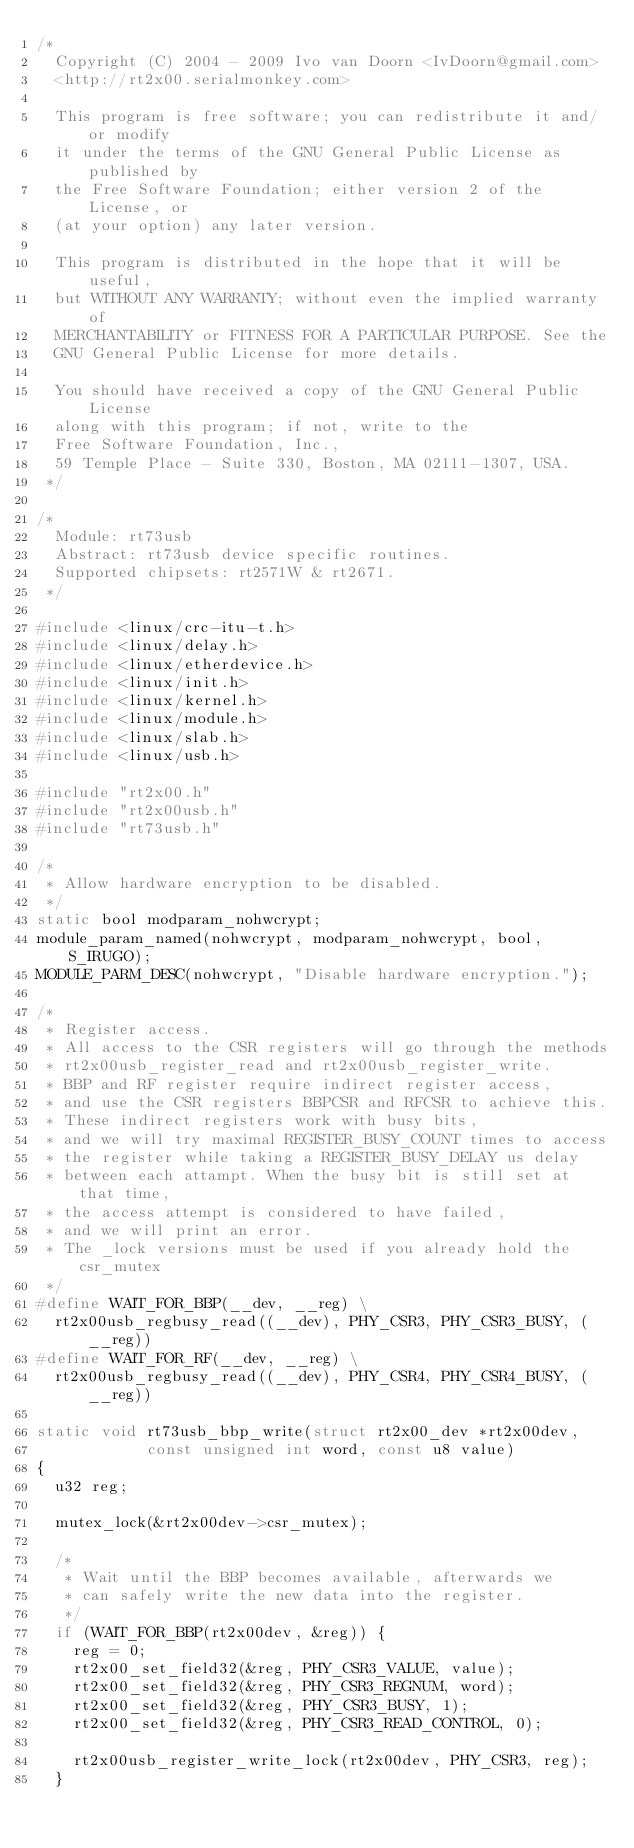<code> <loc_0><loc_0><loc_500><loc_500><_C_>/*
	Copyright (C) 2004 - 2009 Ivo van Doorn <IvDoorn@gmail.com>
	<http://rt2x00.serialmonkey.com>

	This program is free software; you can redistribute it and/or modify
	it under the terms of the GNU General Public License as published by
	the Free Software Foundation; either version 2 of the License, or
	(at your option) any later version.

	This program is distributed in the hope that it will be useful,
	but WITHOUT ANY WARRANTY; without even the implied warranty of
	MERCHANTABILITY or FITNESS FOR A PARTICULAR PURPOSE. See the
	GNU General Public License for more details.

	You should have received a copy of the GNU General Public License
	along with this program; if not, write to the
	Free Software Foundation, Inc.,
	59 Temple Place - Suite 330, Boston, MA 02111-1307, USA.
 */

/*
	Module: rt73usb
	Abstract: rt73usb device specific routines.
	Supported chipsets: rt2571W & rt2671.
 */

#include <linux/crc-itu-t.h>
#include <linux/delay.h>
#include <linux/etherdevice.h>
#include <linux/init.h>
#include <linux/kernel.h>
#include <linux/module.h>
#include <linux/slab.h>
#include <linux/usb.h>

#include "rt2x00.h"
#include "rt2x00usb.h"
#include "rt73usb.h"

/*
 * Allow hardware encryption to be disabled.
 */
static bool modparam_nohwcrypt;
module_param_named(nohwcrypt, modparam_nohwcrypt, bool, S_IRUGO);
MODULE_PARM_DESC(nohwcrypt, "Disable hardware encryption.");

/*
 * Register access.
 * All access to the CSR registers will go through the methods
 * rt2x00usb_register_read and rt2x00usb_register_write.
 * BBP and RF register require indirect register access,
 * and use the CSR registers BBPCSR and RFCSR to achieve this.
 * These indirect registers work with busy bits,
 * and we will try maximal REGISTER_BUSY_COUNT times to access
 * the register while taking a REGISTER_BUSY_DELAY us delay
 * between each attampt. When the busy bit is still set at that time,
 * the access attempt is considered to have failed,
 * and we will print an error.
 * The _lock versions must be used if you already hold the csr_mutex
 */
#define WAIT_FOR_BBP(__dev, __reg) \
	rt2x00usb_regbusy_read((__dev), PHY_CSR3, PHY_CSR3_BUSY, (__reg))
#define WAIT_FOR_RF(__dev, __reg) \
	rt2x00usb_regbusy_read((__dev), PHY_CSR4, PHY_CSR4_BUSY, (__reg))

static void rt73usb_bbp_write(struct rt2x00_dev *rt2x00dev,
			      const unsigned int word, const u8 value)
{
	u32 reg;

	mutex_lock(&rt2x00dev->csr_mutex);

	/*
	 * Wait until the BBP becomes available, afterwards we
	 * can safely write the new data into the register.
	 */
	if (WAIT_FOR_BBP(rt2x00dev, &reg)) {
		reg = 0;
		rt2x00_set_field32(&reg, PHY_CSR3_VALUE, value);
		rt2x00_set_field32(&reg, PHY_CSR3_REGNUM, word);
		rt2x00_set_field32(&reg, PHY_CSR3_BUSY, 1);
		rt2x00_set_field32(&reg, PHY_CSR3_READ_CONTROL, 0);

		rt2x00usb_register_write_lock(rt2x00dev, PHY_CSR3, reg);
	}
</code> 